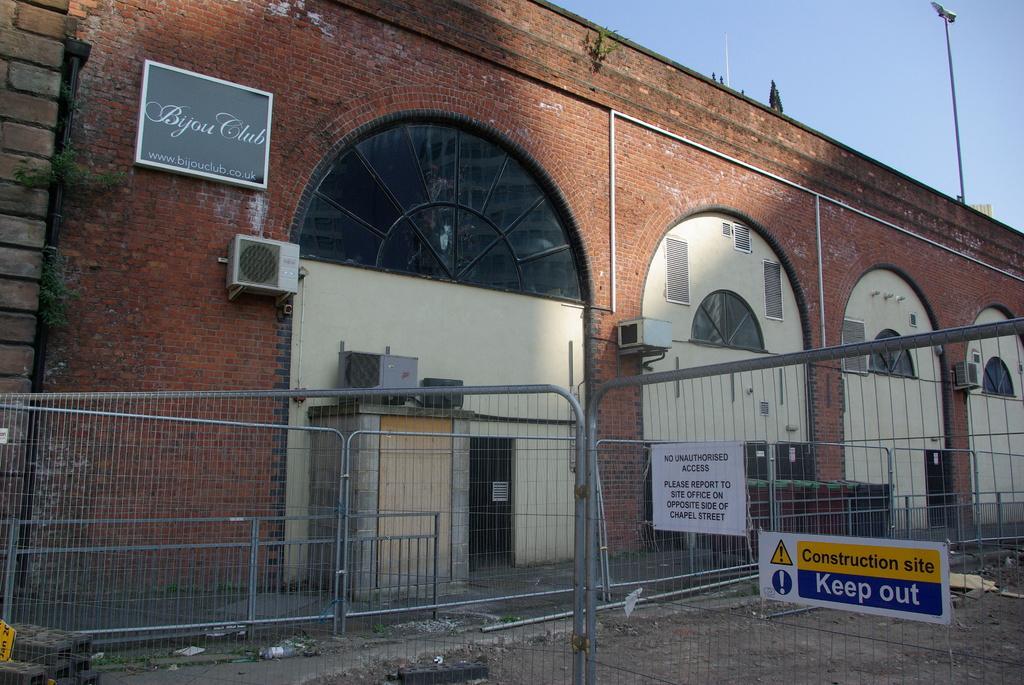Could you give a brief overview of what you see in this image? In the picture we can see the building wall with bricks and near to it we can see a railing and on the top of the wall we can see a pole and behind it we can see a part of the sky. 